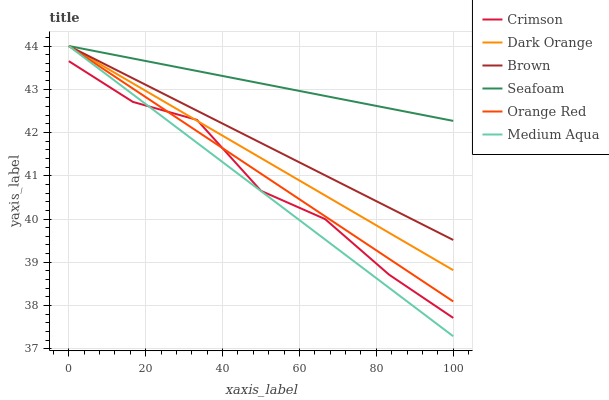Does Brown have the minimum area under the curve?
Answer yes or no. No. Does Brown have the maximum area under the curve?
Answer yes or no. No. Is Seafoam the smoothest?
Answer yes or no. No. Is Seafoam the roughest?
Answer yes or no. No. Does Brown have the lowest value?
Answer yes or no. No. Does Crimson have the highest value?
Answer yes or no. No. Is Crimson less than Brown?
Answer yes or no. Yes. Is Brown greater than Crimson?
Answer yes or no. Yes. Does Crimson intersect Brown?
Answer yes or no. No. 